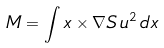<formula> <loc_0><loc_0><loc_500><loc_500>M = \int x \times \nabla S \, u ^ { 2 } \, d x</formula> 